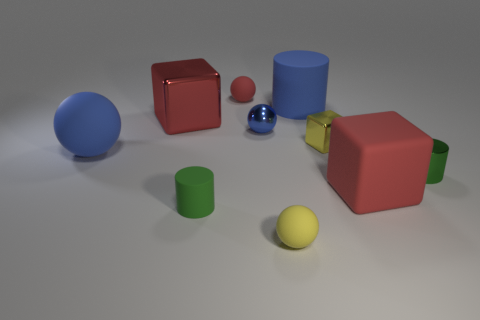Is the number of brown spheres greater than the number of tiny blue metallic objects?
Give a very brief answer. No. Is there a small object of the same shape as the large red matte thing?
Offer a terse response. Yes. The big red thing right of the large rubber cylinder has what shape?
Your answer should be compact. Cube. There is a small green metallic thing to the right of the large cube that is behind the small blue object; how many red cubes are right of it?
Provide a short and direct response. 0. There is a large cube that is on the left side of the big cylinder; is it the same color as the tiny block?
Your answer should be very brief. No. How many other things are the same shape as the large red metal thing?
Offer a very short reply. 2. How many other things are the same material as the large sphere?
Provide a succinct answer. 5. What material is the block to the left of the big rubber object that is behind the red cube that is left of the yellow matte sphere?
Ensure brevity in your answer.  Metal. Do the tiny blue object and the red sphere have the same material?
Offer a very short reply. No. How many cubes are small yellow metallic things or tiny matte things?
Your answer should be compact. 1. 